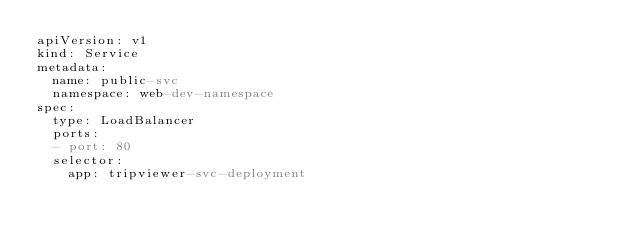<code> <loc_0><loc_0><loc_500><loc_500><_YAML_>apiVersion: v1
kind: Service
metadata:
  name: public-svc
  namespace: web-dev-namespace
spec:
  type: LoadBalancer
  ports:
  - port: 80
  selector:
    app: tripviewer-svc-deployment</code> 